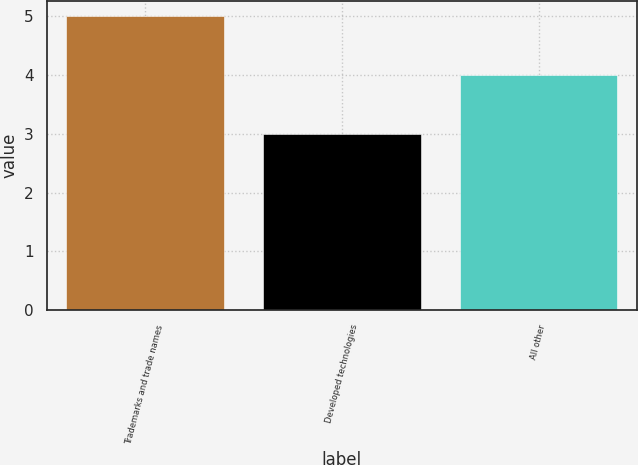Convert chart. <chart><loc_0><loc_0><loc_500><loc_500><bar_chart><fcel>Trademarks and trade names<fcel>Developed technologies<fcel>All other<nl><fcel>5<fcel>3<fcel>4<nl></chart> 